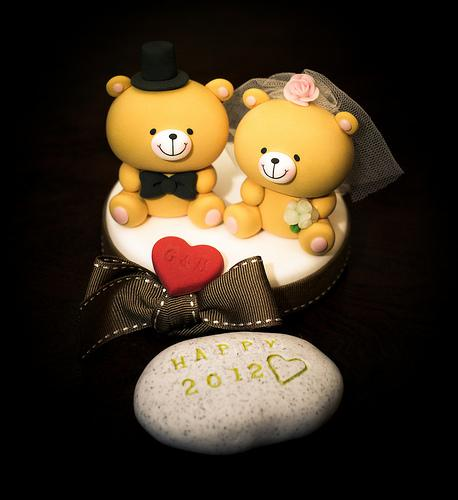Question: who is in the room?
Choices:
A. A man.
B. A woman.
C. No one.
D. A boy.
Answer with the letter. Answer: C Question: what is written?
Choices:
A. Happy 2012.
B. Happy thanksgiving.
C. Merry Christmas.
D. Happy 2121.
Answer with the letter. Answer: A Question: why are the dolls smiling?
Choices:
A. They were painted that way.
B. They are laughing.
C. They enjoy being dolls.
D. They Are happy.
Answer with the letter. Answer: D 